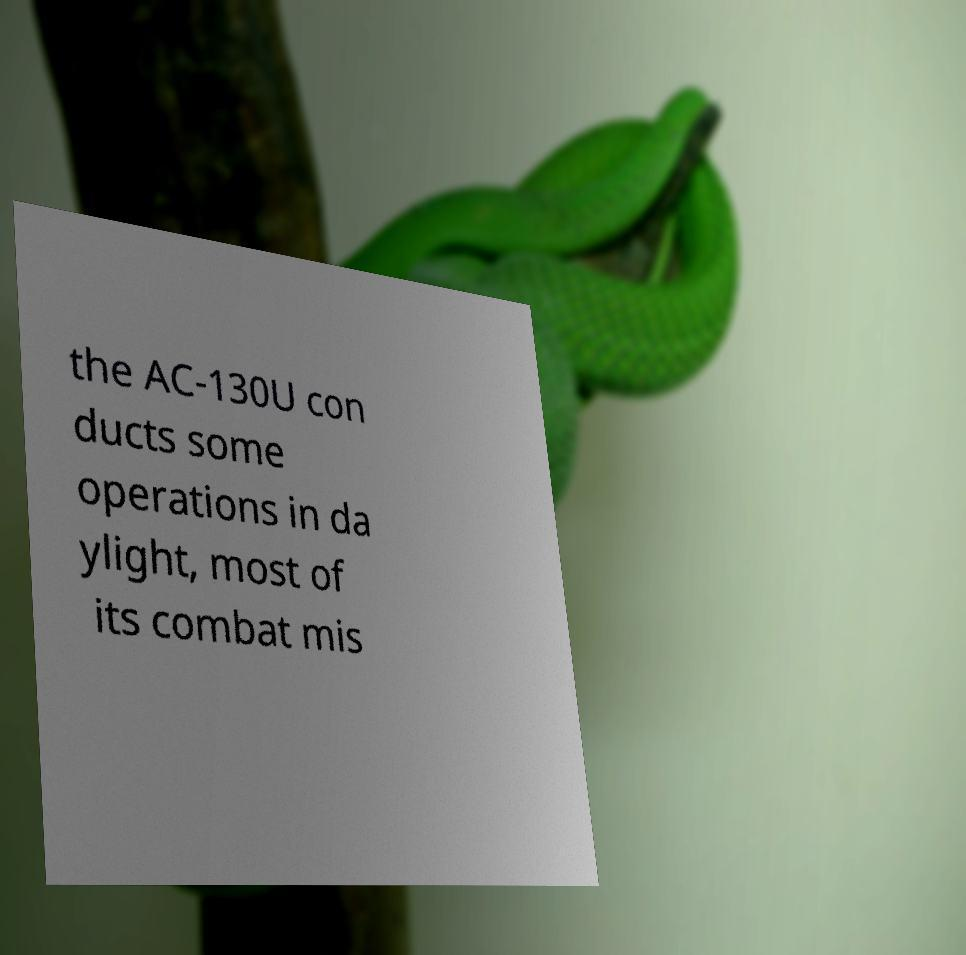Please identify and transcribe the text found in this image. the AC-130U con ducts some operations in da ylight, most of its combat mis 